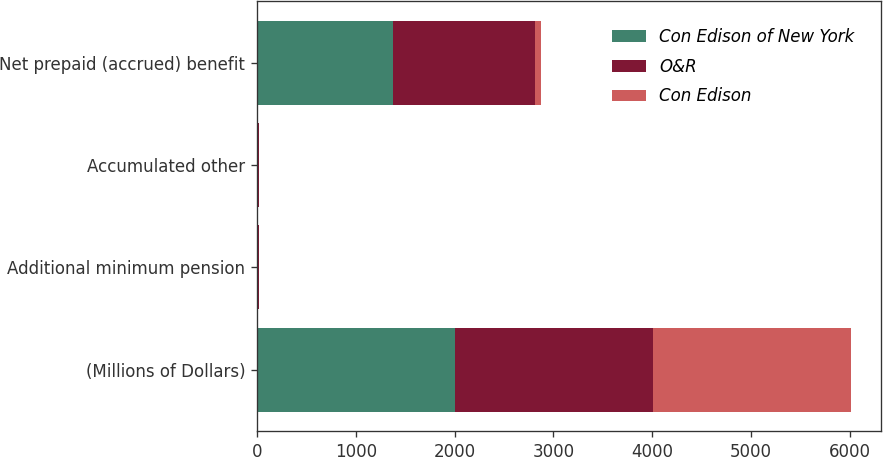Convert chart to OTSL. <chart><loc_0><loc_0><loc_500><loc_500><stacked_bar_chart><ecel><fcel>(Millions of Dollars)<fcel>Additional minimum pension<fcel>Accumulated other<fcel>Net prepaid (accrued) benefit<nl><fcel>Con Edison of New York<fcel>2004<fcel>12<fcel>12<fcel>1377<nl><fcel>O&R<fcel>2004<fcel>11<fcel>11<fcel>1435<nl><fcel>Con Edison<fcel>2004<fcel>1<fcel>1<fcel>58<nl></chart> 